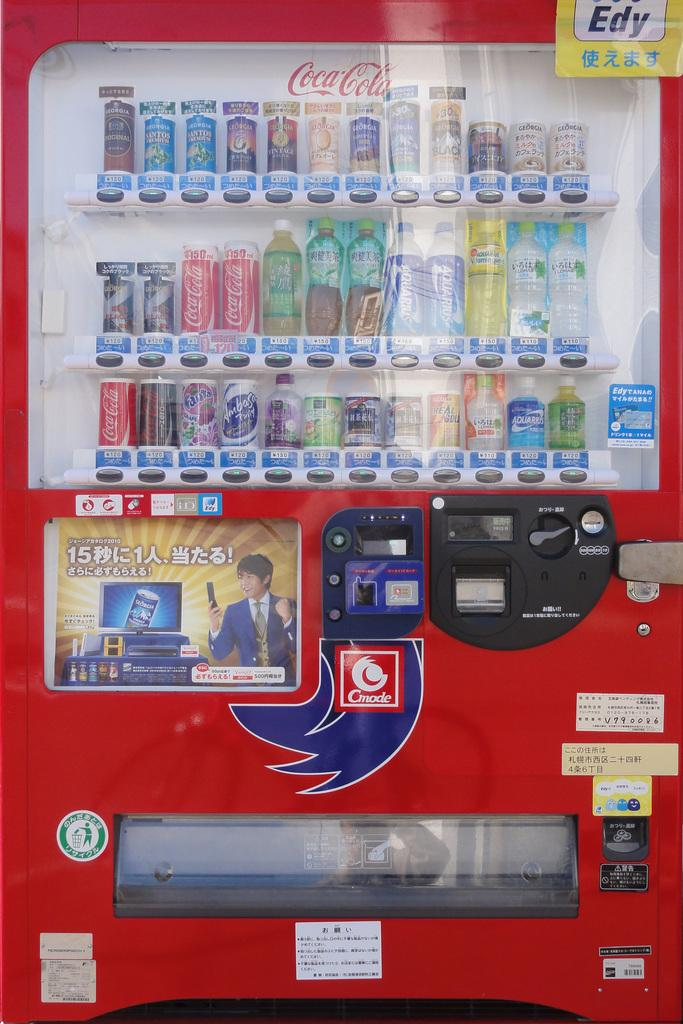What is the main object in the image? There is a machine in the image. What is inside the machine? The machine contains bottles and tins. Are there any additional decorations or features on the machine? Yes, there are posters on the machine. What type of whip can be seen cracking near the machine in the image? There is no whip present in the image. What kind of destruction can be observed happening to the machine in the image? There is no destruction happening to the machine in the image; it appears to be intact. 